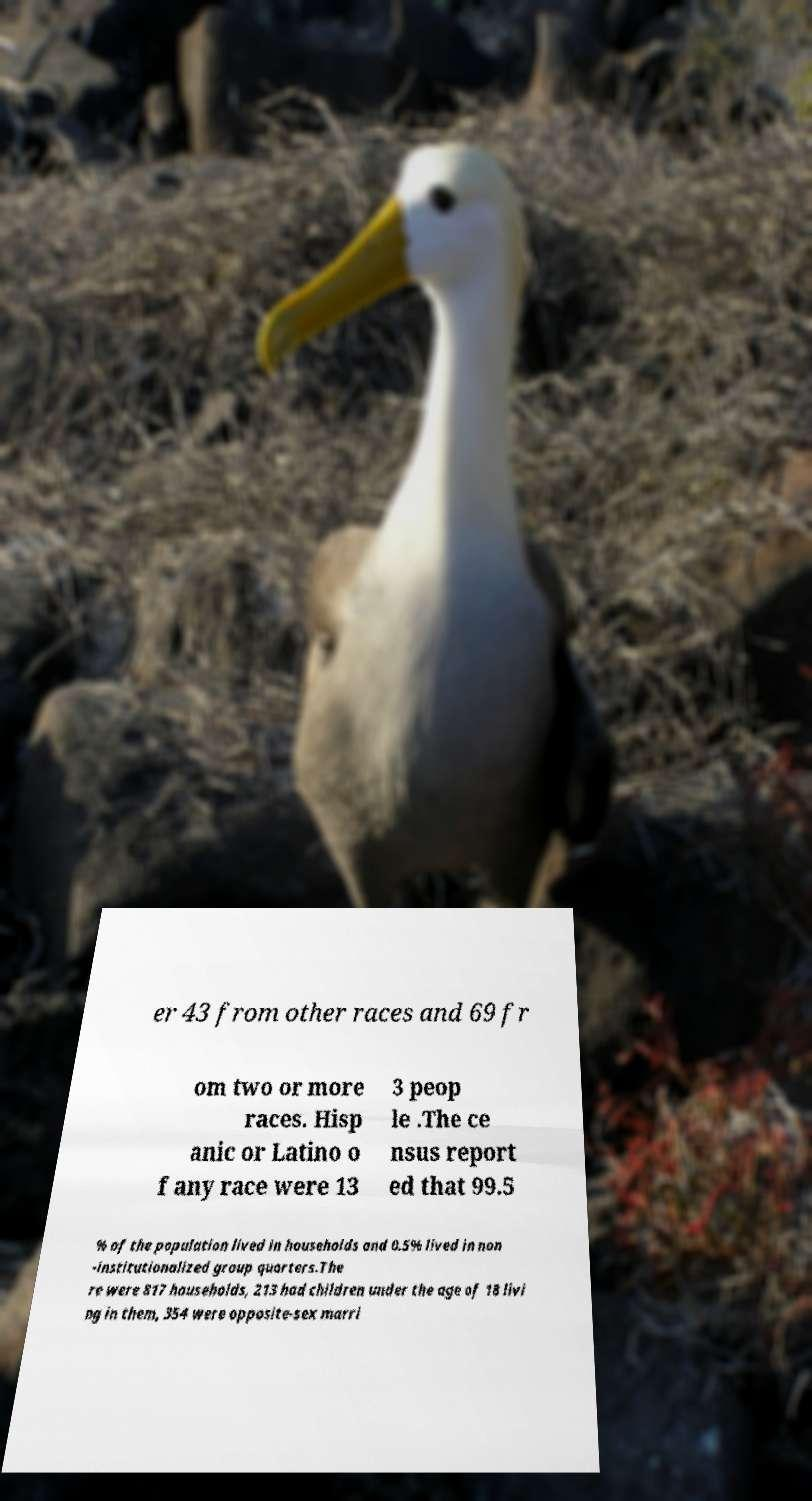Please identify and transcribe the text found in this image. er 43 from other races and 69 fr om two or more races. Hisp anic or Latino o f any race were 13 3 peop le .The ce nsus report ed that 99.5 % of the population lived in households and 0.5% lived in non -institutionalized group quarters.The re were 817 households, 213 had children under the age of 18 livi ng in them, 354 were opposite-sex marri 